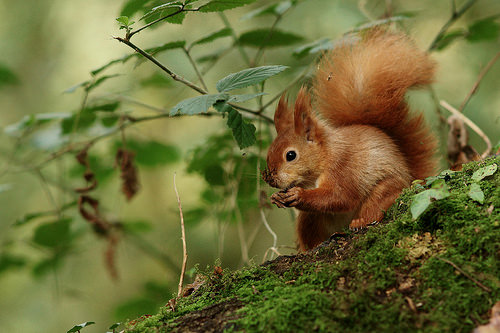<image>
Can you confirm if the squirrel is to the left of the plant? No. The squirrel is not to the left of the plant. From this viewpoint, they have a different horizontal relationship. Is the squirrel to the right of the log? No. The squirrel is not to the right of the log. The horizontal positioning shows a different relationship. 